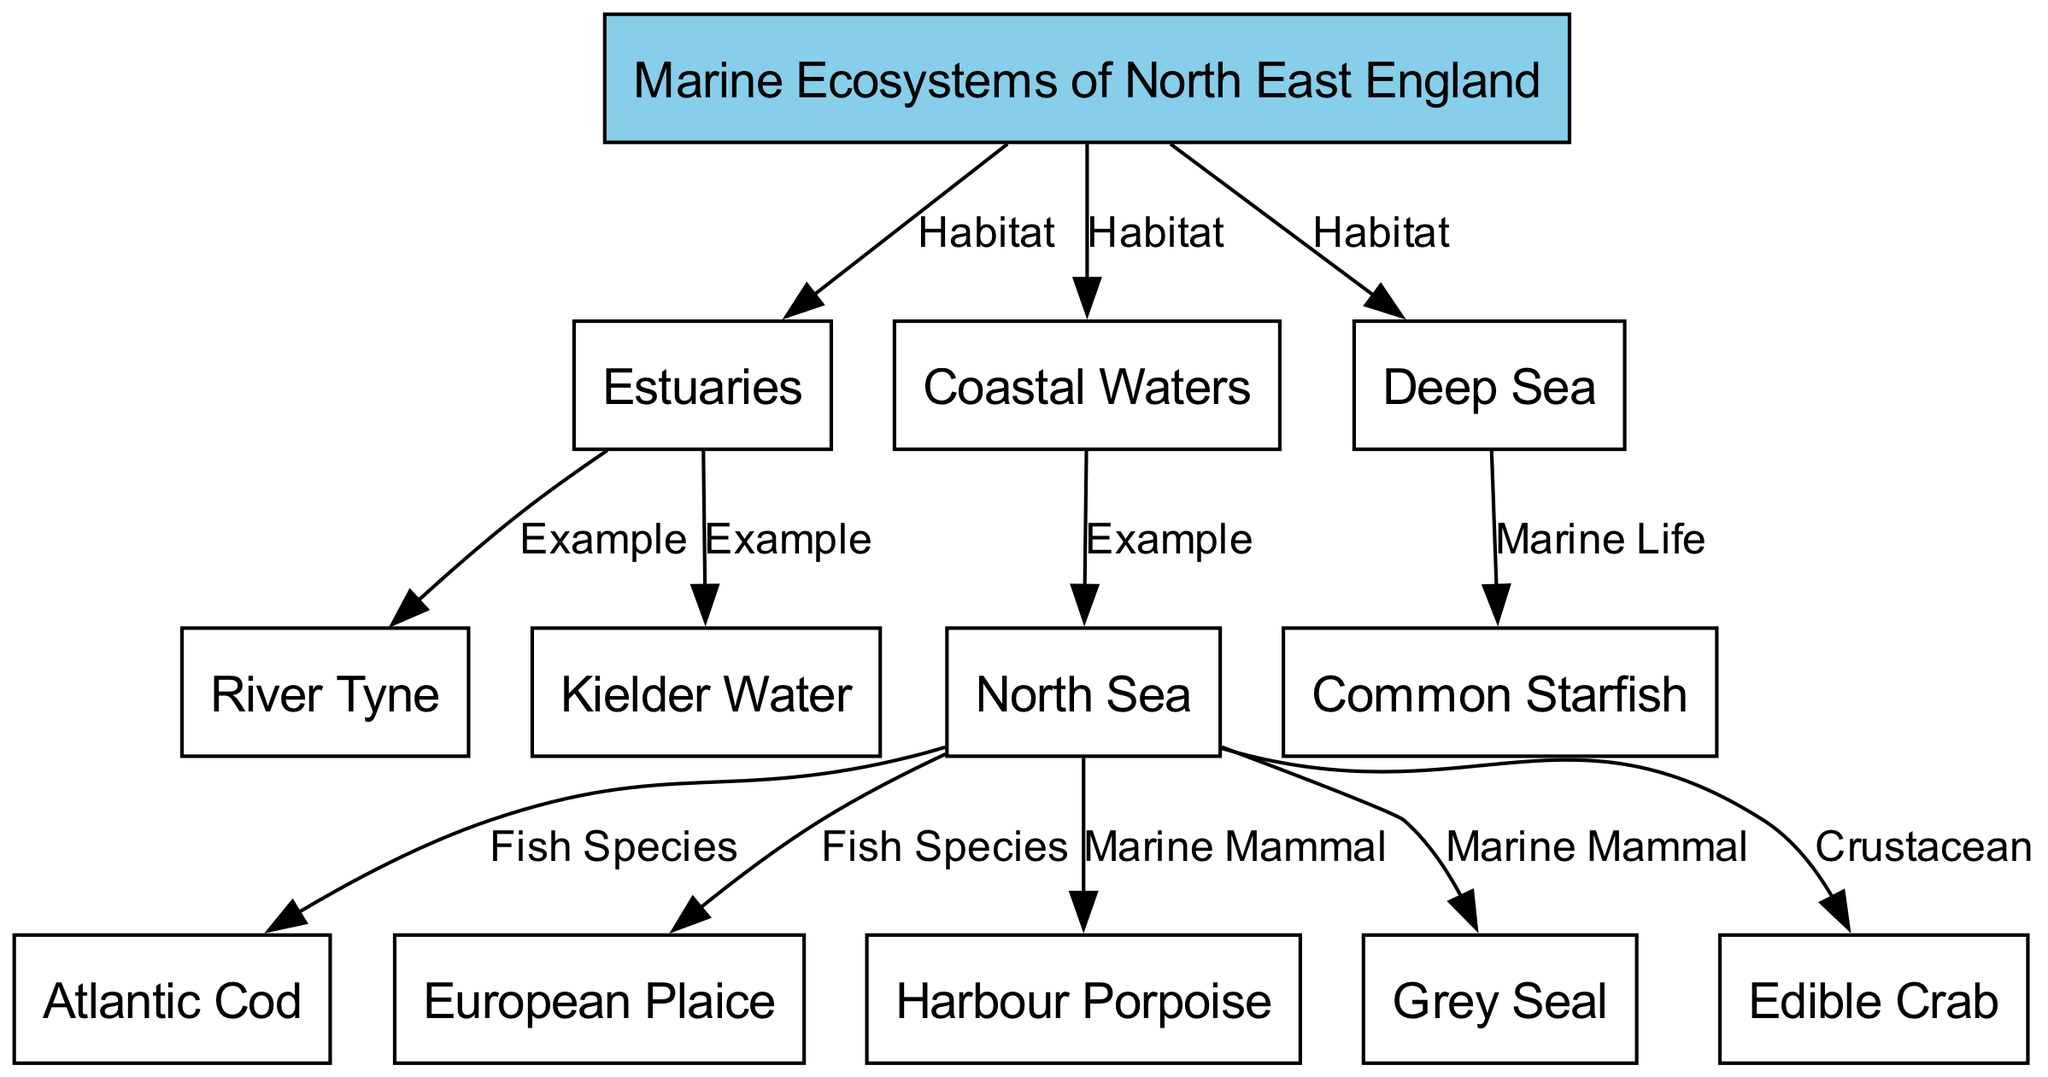What are the three main habitats in the marine ecosystems of North East England? The diagram shows three main habitats: Estuaries, Coastal Waters, and Deep Sea, which are all connected to the main node labeled "Marine Ecosystems of North East England."
Answer: Estuaries, Coastal Waters, Deep Sea Which example is listed for Coastal Waters? The edge from Coastal Waters indicates that the North Sea is an example of this habitat. The label on the edge specifically states "Example" pointing from Coastal Waters to the North Sea.
Answer: North Sea How many species of fish are mentioned in the diagram? The diagram connects two fish species, Atlantic Cod and European Plaice, to the North Sea and identifies them as "Fish Species." Counting these, we find two species labeled on the edges.
Answer: 2 What marine mammal is associated with the North Sea? The North Sea is connected to two marine mammals in the diagram: Harbour Porpoise and Grey Seal. Thus, either mammal can be correctly associated with this habitat. Each is connected via a label stating "Marine Mammal."
Answer: Harbour Porpoise (or Grey Seal) What type of organism is the Common Starfish? The diagram shows that the Common Starfish is categorized under "Marine Life" and is directly linked to the Deep Sea. It indicates its classification using the label "Marine Life."
Answer: Marine Life 